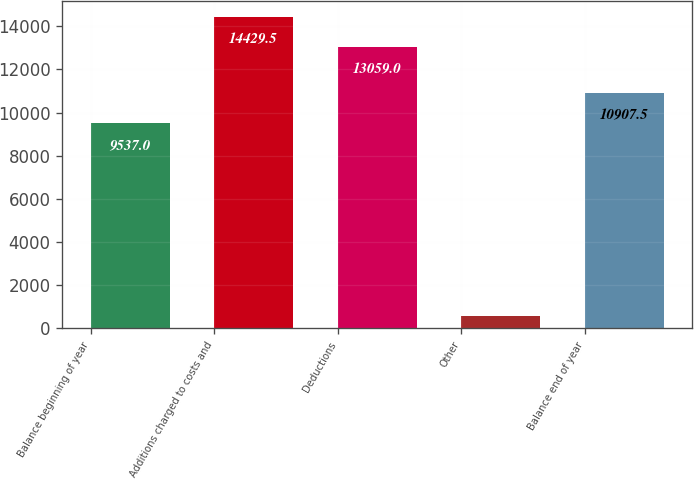Convert chart. <chart><loc_0><loc_0><loc_500><loc_500><bar_chart><fcel>Balance beginning of year<fcel>Additions charged to costs and<fcel>Deductions<fcel>Other<fcel>Balance end of year<nl><fcel>9537<fcel>14429.5<fcel>13059<fcel>579<fcel>10907.5<nl></chart> 